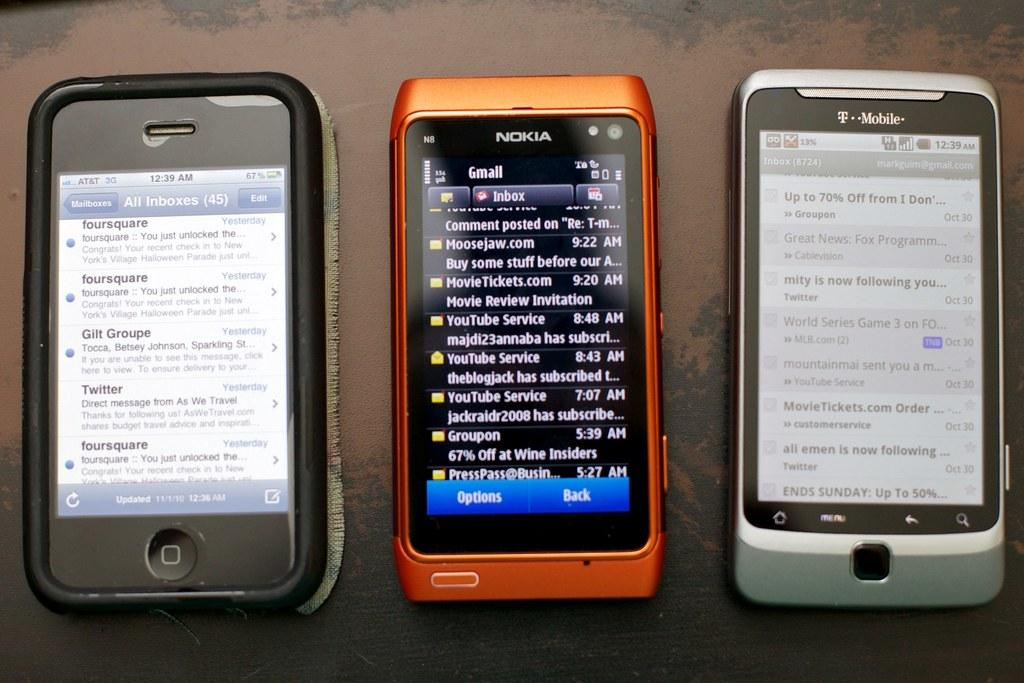<image>
Create a compact narrative representing the image presented. A black phone, an orange Nokia phone, and a silver T Mobile phone all lined up and turned on. 